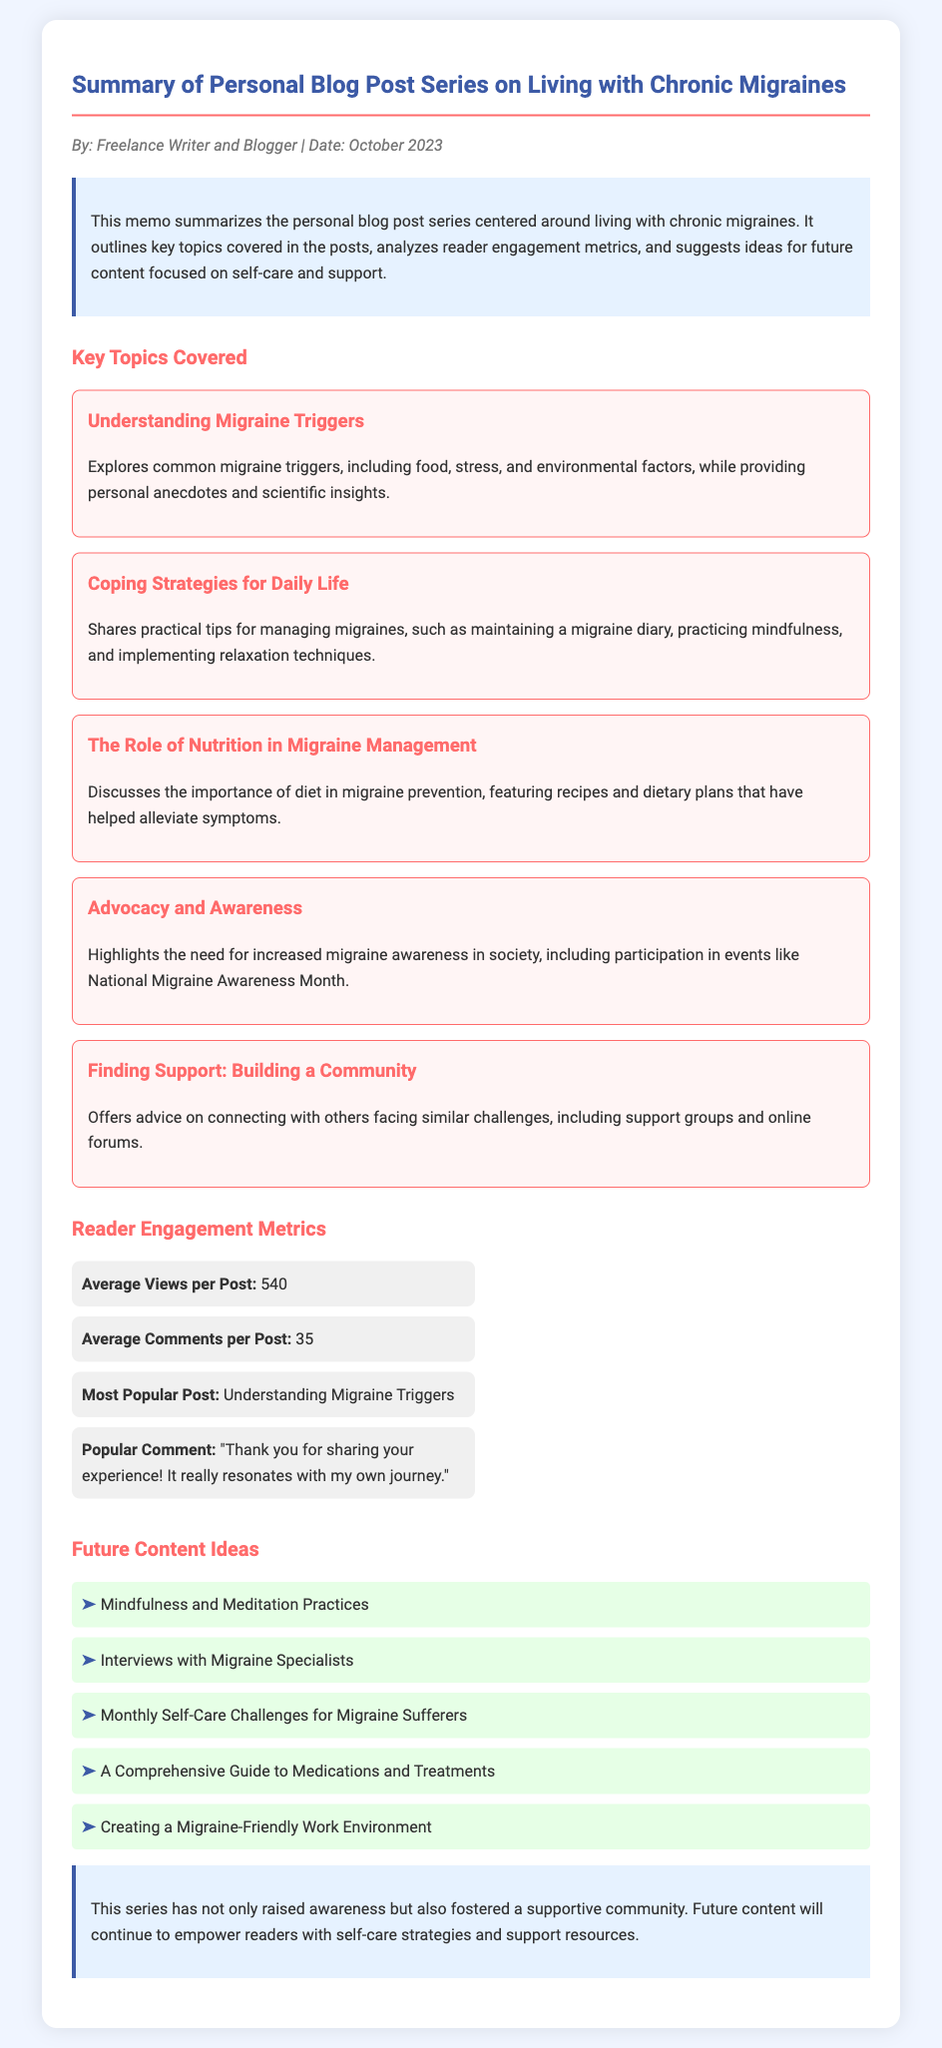what is the title of the memo? The title of the memo is presented at the top of the document.
Answer: Summary of Personal Blog Post Series on Living with Chronic Migraines who is the author of the memo? The author's name is listed in the author-date section of the document.
Answer: Freelance Writer and Blogger what is the date of the memo? The date is shown in the author-date section right after the author's name.
Answer: October 2023 what is the average number of views per post? The average views metric is explicitly stated in the reader engagement metrics section.
Answer: 540 which post is the most popular? The most popular post is highlighted in the reader engagement metrics.
Answer: Understanding Migraine Triggers what topic covers common migraine triggers, including food and stress? This topic is specifically mentioned among the key topics covered in the blog series.
Answer: Understanding Migraine Triggers how many average comments does each post receive? The average comments metric can be found in the reader engagement metrics section.
Answer: 35 what is one future content idea suggested in the memo? Future content ideas are listed in the respective section; one example is explicitly named.
Answer: Mindfulness and Meditation Practices what overarching theme does the series aim to achieve? This theme is summarized in the conclusion section of the memo.
Answer: Raising awareness and fostering a supportive community 